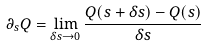Convert formula to latex. <formula><loc_0><loc_0><loc_500><loc_500>\partial _ { s } Q = \lim _ { \delta s \rightarrow 0 } \frac { Q ( s + \delta s ) - Q ( s ) } { \delta s }</formula> 